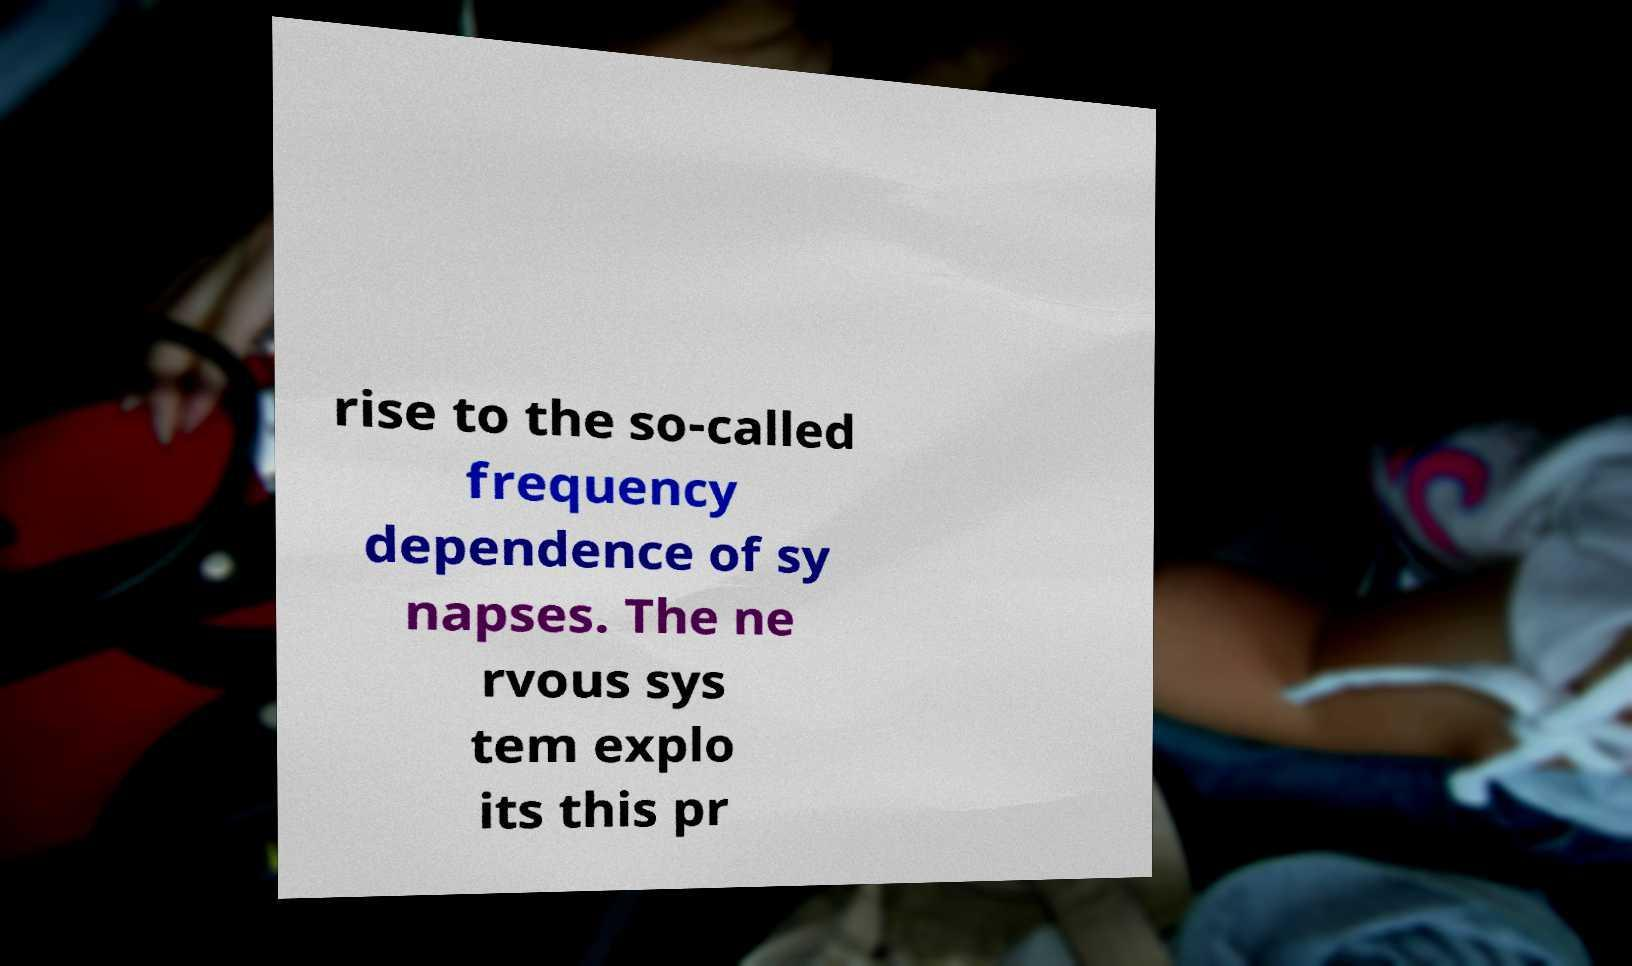Can you read and provide the text displayed in the image?This photo seems to have some interesting text. Can you extract and type it out for me? rise to the so-called frequency dependence of sy napses. The ne rvous sys tem explo its this pr 